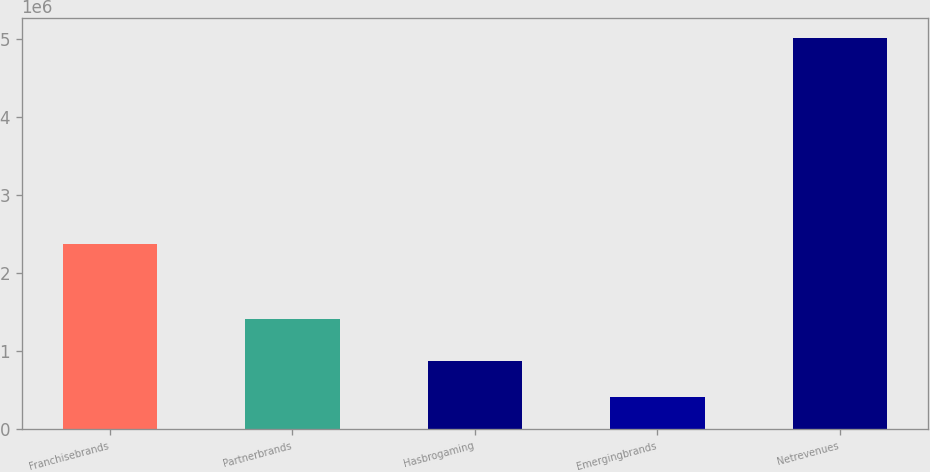<chart> <loc_0><loc_0><loc_500><loc_500><bar_chart><fcel>Franchisebrands<fcel>Partnerbrands<fcel>Hasbrogaming<fcel>Emergingbrands<fcel>Netrevenues<nl><fcel>2.37526e+06<fcel>1.41277e+06<fcel>878501<fcel>418354<fcel>5.01982e+06<nl></chart> 